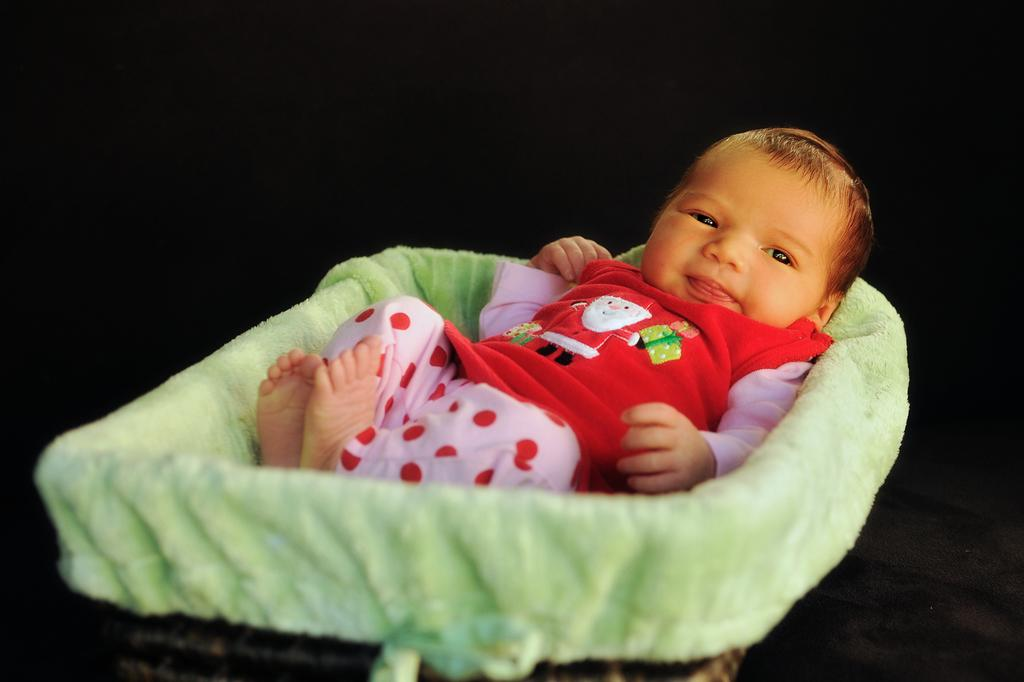What is the main subject of the image? The main subject of the image is a kid. What is the kid doing in the image? The kid is laying on a cloth. What color is the background of the image? The background of the image is black. What type of net can be seen in the image? There is no net present in the image. Is the kid playing baseball in the image? There is no indication of the kid playing baseball or any other sport in the image. 